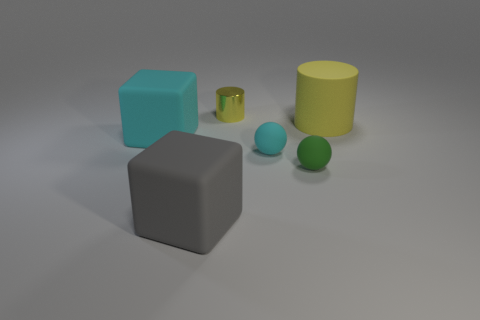Subtract all cyan cubes. How many cubes are left? 1 Add 3 gray things. How many objects exist? 9 Subtract 1 spheres. How many spheres are left? 1 Add 4 matte things. How many matte things are left? 9 Add 2 large yellow cylinders. How many large yellow cylinders exist? 3 Subtract 0 red balls. How many objects are left? 6 Subtract all brown cylinders. Subtract all blue cubes. How many cylinders are left? 2 Subtract all red blocks. How many purple cylinders are left? 0 Subtract all small purple metallic cylinders. Subtract all small cylinders. How many objects are left? 5 